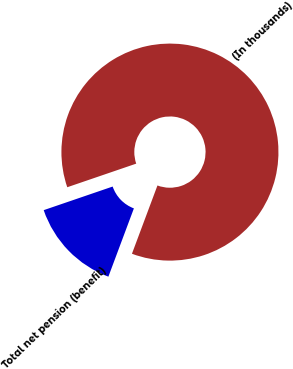<chart> <loc_0><loc_0><loc_500><loc_500><pie_chart><fcel>(In thousands)<fcel>Total net pension (benefit)<nl><fcel>85.94%<fcel>14.06%<nl></chart> 